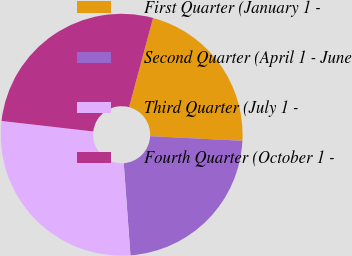Convert chart to OTSL. <chart><loc_0><loc_0><loc_500><loc_500><pie_chart><fcel>First Quarter (January 1 -<fcel>Second Quarter (April 1 - June<fcel>Third Quarter (July 1 -<fcel>Fourth Quarter (October 1 -<nl><fcel>21.61%<fcel>23.04%<fcel>27.98%<fcel>27.37%<nl></chart> 